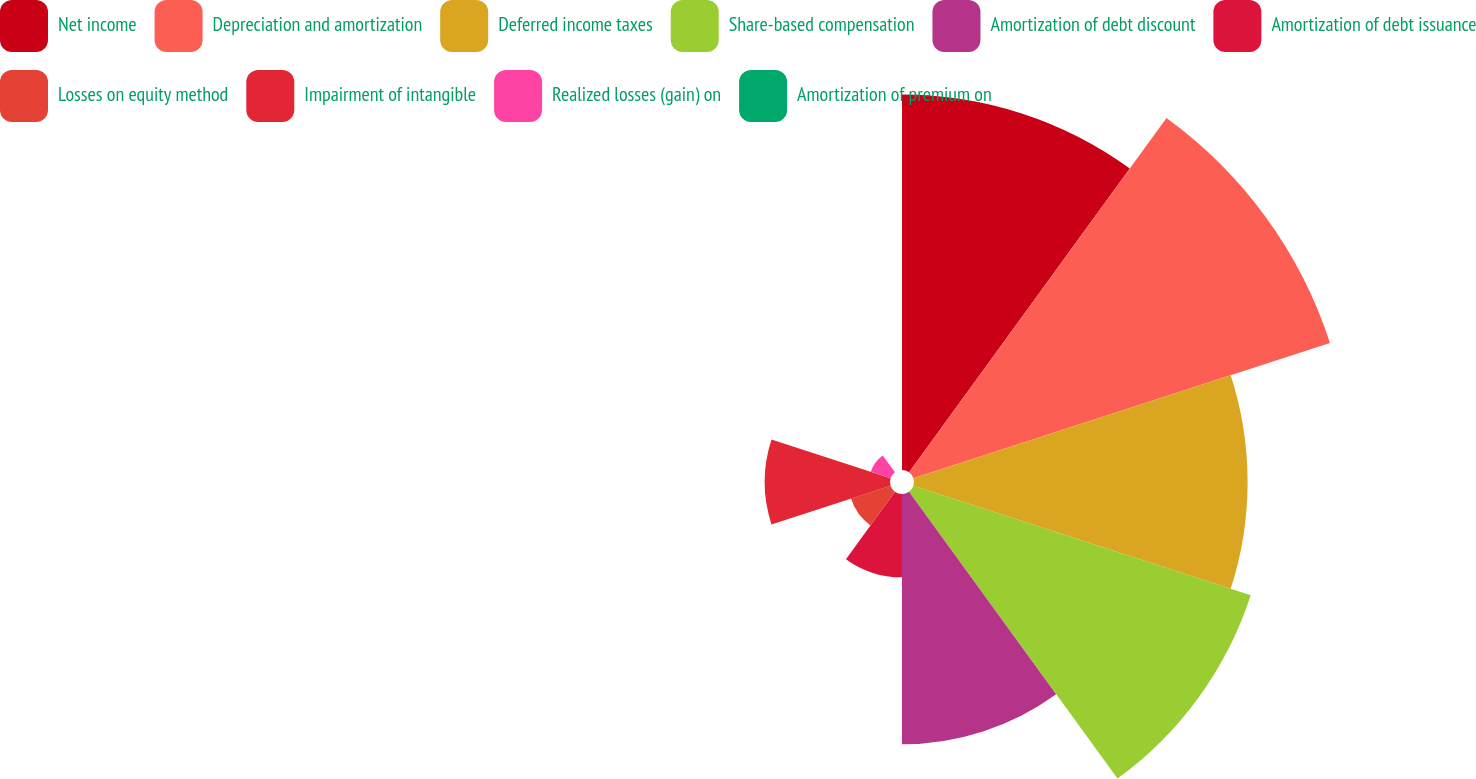Convert chart to OTSL. <chart><loc_0><loc_0><loc_500><loc_500><pie_chart><fcel>Net income<fcel>Depreciation and amortization<fcel>Deferred income taxes<fcel>Share-based compensation<fcel>Amortization of debt discount<fcel>Amortization of debt issuance<fcel>Losses on equity method<fcel>Impairment of intangible<fcel>Realized losses (gain) on<fcel>Amortization of premium on<nl><fcel>18.56%<fcel>21.65%<fcel>16.49%<fcel>17.53%<fcel>12.37%<fcel>4.12%<fcel>2.06%<fcel>6.19%<fcel>1.03%<fcel>0.0%<nl></chart> 